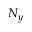Convert formula to latex. <formula><loc_0><loc_0><loc_500><loc_500>N _ { y }</formula> 